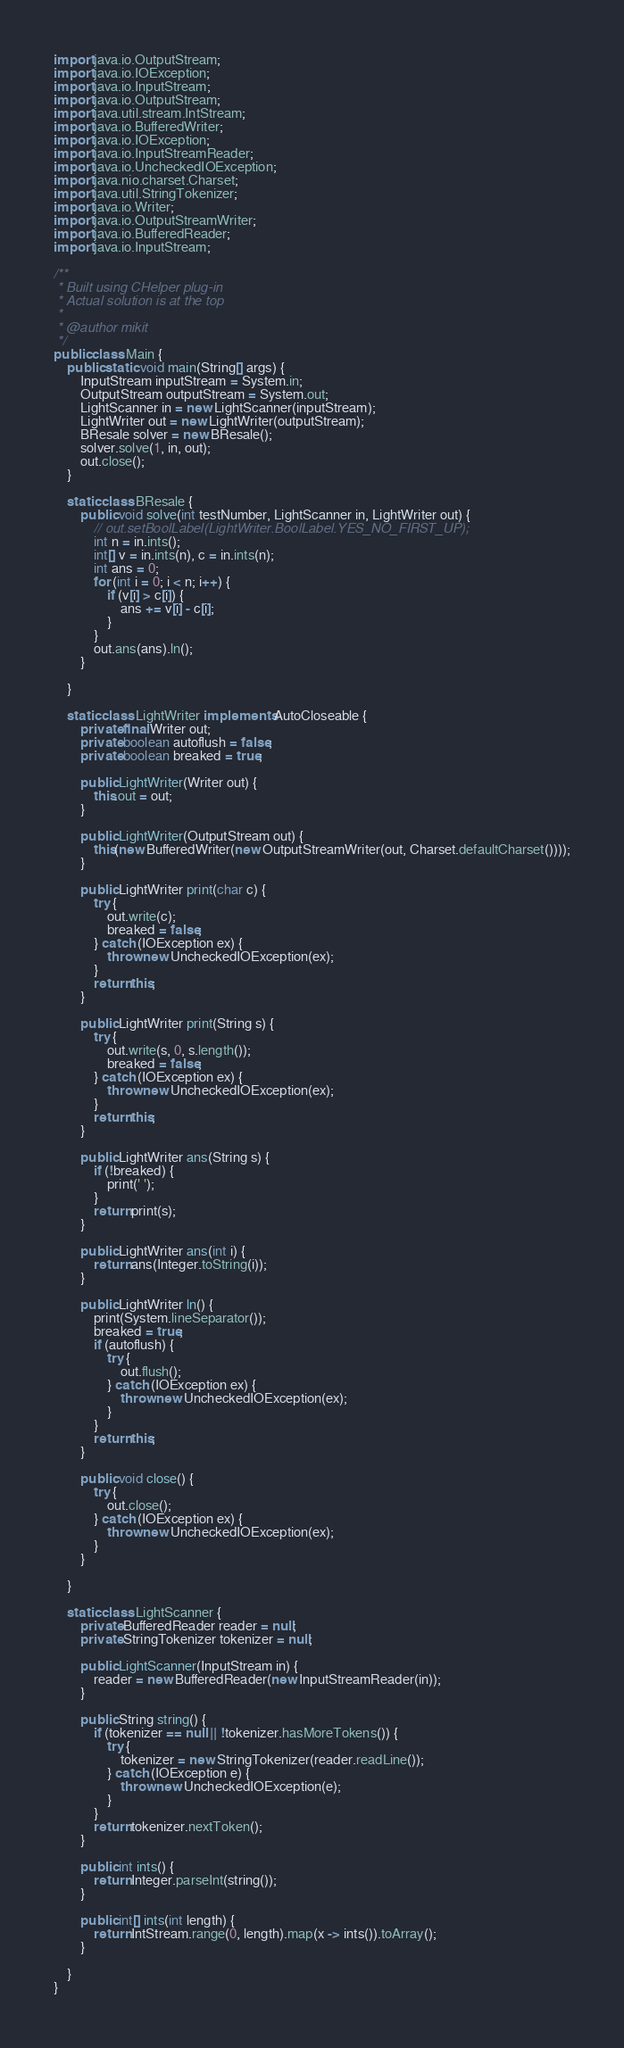Convert code to text. <code><loc_0><loc_0><loc_500><loc_500><_Java_>import java.io.OutputStream;
import java.io.IOException;
import java.io.InputStream;
import java.io.OutputStream;
import java.util.stream.IntStream;
import java.io.BufferedWriter;
import java.io.IOException;
import java.io.InputStreamReader;
import java.io.UncheckedIOException;
import java.nio.charset.Charset;
import java.util.StringTokenizer;
import java.io.Writer;
import java.io.OutputStreamWriter;
import java.io.BufferedReader;
import java.io.InputStream;

/**
 * Built using CHelper plug-in
 * Actual solution is at the top
 *
 * @author mikit
 */
public class Main {
    public static void main(String[] args) {
        InputStream inputStream = System.in;
        OutputStream outputStream = System.out;
        LightScanner in = new LightScanner(inputStream);
        LightWriter out = new LightWriter(outputStream);
        BResale solver = new BResale();
        solver.solve(1, in, out);
        out.close();
    }

    static class BResale {
        public void solve(int testNumber, LightScanner in, LightWriter out) {
            // out.setBoolLabel(LightWriter.BoolLabel.YES_NO_FIRST_UP);
            int n = in.ints();
            int[] v = in.ints(n), c = in.ints(n);
            int ans = 0;
            for (int i = 0; i < n; i++) {
                if (v[i] > c[i]) {
                    ans += v[i] - c[i];
                }
            }
            out.ans(ans).ln();
        }

    }

    static class LightWriter implements AutoCloseable {
        private final Writer out;
        private boolean autoflush = false;
        private boolean breaked = true;

        public LightWriter(Writer out) {
            this.out = out;
        }

        public LightWriter(OutputStream out) {
            this(new BufferedWriter(new OutputStreamWriter(out, Charset.defaultCharset())));
        }

        public LightWriter print(char c) {
            try {
                out.write(c);
                breaked = false;
            } catch (IOException ex) {
                throw new UncheckedIOException(ex);
            }
            return this;
        }

        public LightWriter print(String s) {
            try {
                out.write(s, 0, s.length());
                breaked = false;
            } catch (IOException ex) {
                throw new UncheckedIOException(ex);
            }
            return this;
        }

        public LightWriter ans(String s) {
            if (!breaked) {
                print(' ');
            }
            return print(s);
        }

        public LightWriter ans(int i) {
            return ans(Integer.toString(i));
        }

        public LightWriter ln() {
            print(System.lineSeparator());
            breaked = true;
            if (autoflush) {
                try {
                    out.flush();
                } catch (IOException ex) {
                    throw new UncheckedIOException(ex);
                }
            }
            return this;
        }

        public void close() {
            try {
                out.close();
            } catch (IOException ex) {
                throw new UncheckedIOException(ex);
            }
        }

    }

    static class LightScanner {
        private BufferedReader reader = null;
        private StringTokenizer tokenizer = null;

        public LightScanner(InputStream in) {
            reader = new BufferedReader(new InputStreamReader(in));
        }

        public String string() {
            if (tokenizer == null || !tokenizer.hasMoreTokens()) {
                try {
                    tokenizer = new StringTokenizer(reader.readLine());
                } catch (IOException e) {
                    throw new UncheckedIOException(e);
                }
            }
            return tokenizer.nextToken();
        }

        public int ints() {
            return Integer.parseInt(string());
        }

        public int[] ints(int length) {
            return IntStream.range(0, length).map(x -> ints()).toArray();
        }

    }
}

</code> 